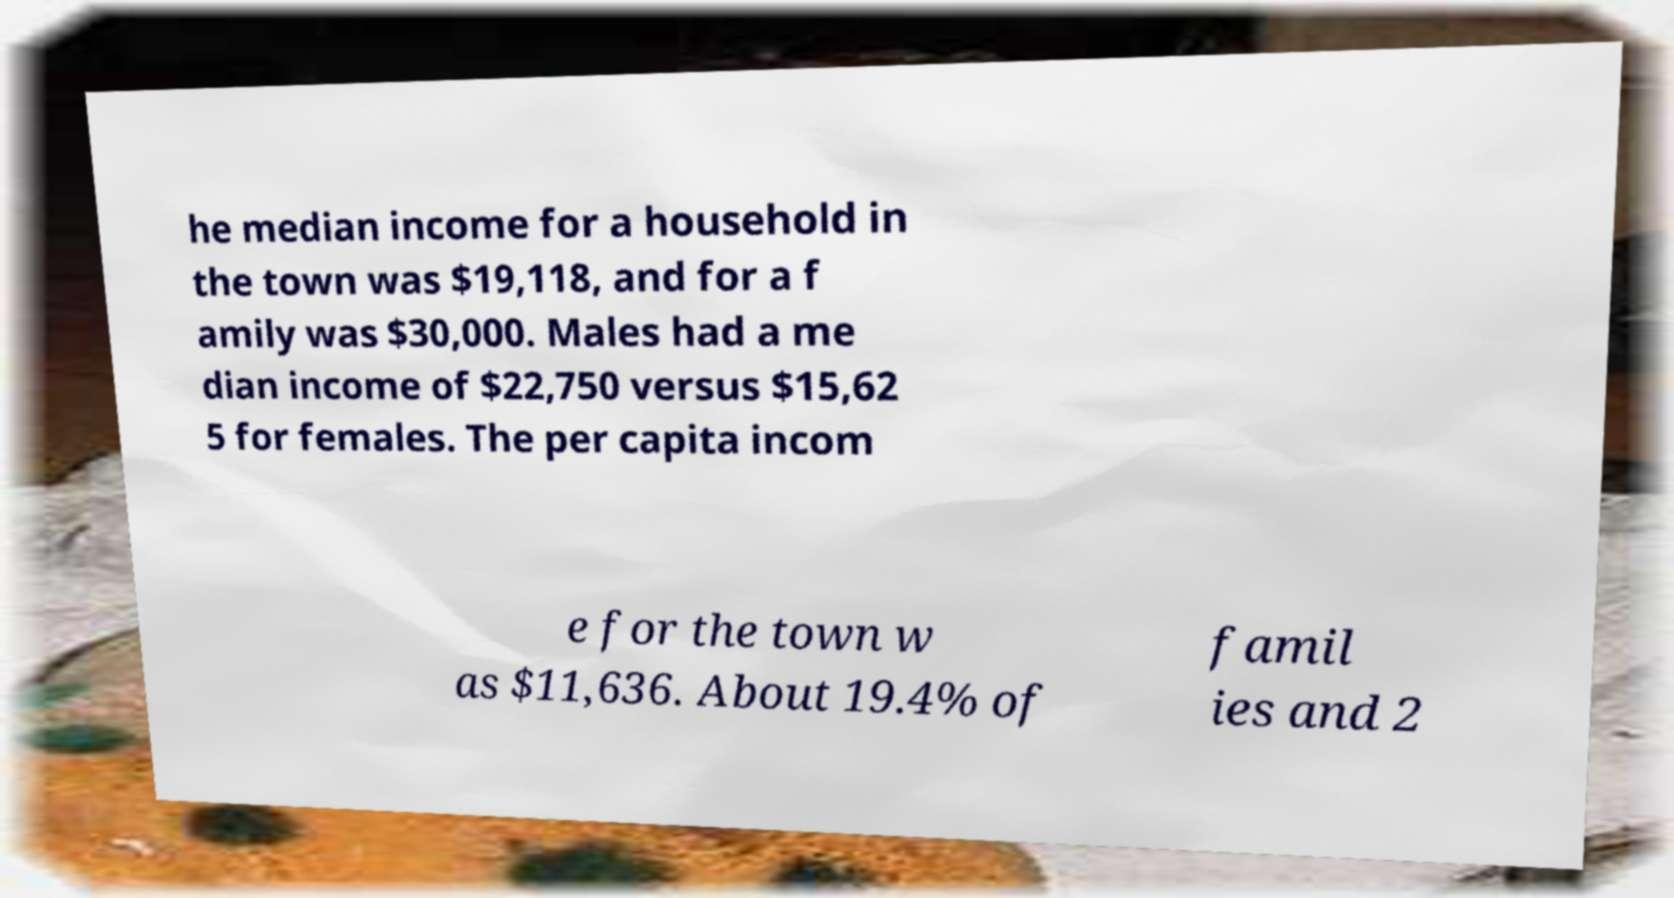I need the written content from this picture converted into text. Can you do that? he median income for a household in the town was $19,118, and for a f amily was $30,000. Males had a me dian income of $22,750 versus $15,62 5 for females. The per capita incom e for the town w as $11,636. About 19.4% of famil ies and 2 